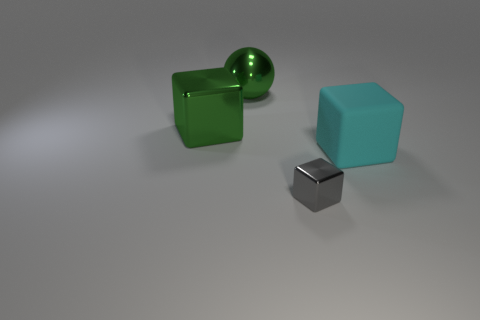The metallic block that is in front of the large cube that is on the right side of the metal block that is in front of the big cyan cube is what color? The metallic block in question exhibits a silver or chrome finish, consistent with what one would expect from polished metal. Its reflective surface mirrors the environment around it, emanating a glossy and sleek appearance. 